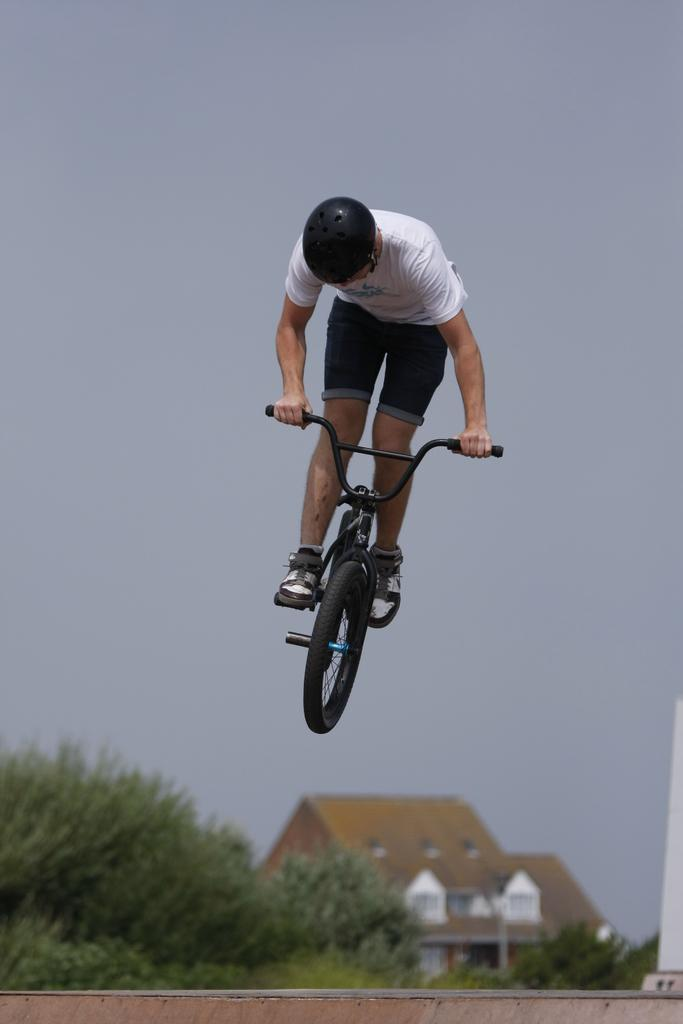What type of vegetation can be seen in the image? There are trees in the image. What type of structures are visible in the image? There are houses in the image. What is visible in the background of the image? The sky is visible in the image. What activity is the man in the image engaged in? The man is riding a bicycle in the image. How many pins can be seen attached to the trees in the image? There are no pins visible in the image; it features trees, houses, the sky, and a man riding a bicycle. What type of creatures are crawling on the houses in the image? There are no creatures visible in the image; it features trees, houses, the sky, and a man riding a bicycle. 